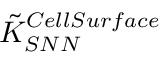Convert formula to latex. <formula><loc_0><loc_0><loc_500><loc_500>\tilde { K } _ { S N N } ^ { C e l l S u r f a c e }</formula> 